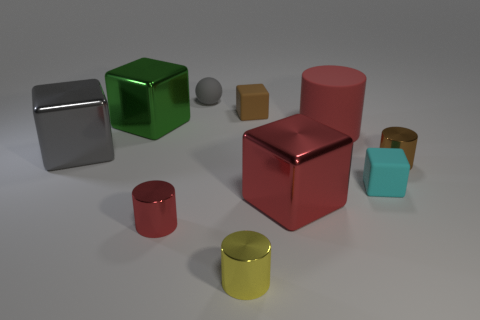Subtract 1 cylinders. How many cylinders are left? 3 Subtract all small cyan blocks. How many blocks are left? 4 Subtract all green cubes. How many cubes are left? 4 Subtract all yellow cubes. Subtract all brown cylinders. How many cubes are left? 5 Subtract all balls. How many objects are left? 9 Subtract all tiny gray blocks. Subtract all green objects. How many objects are left? 9 Add 9 big red blocks. How many big red blocks are left? 10 Add 5 red metal things. How many red metal things exist? 7 Subtract 0 blue spheres. How many objects are left? 10 